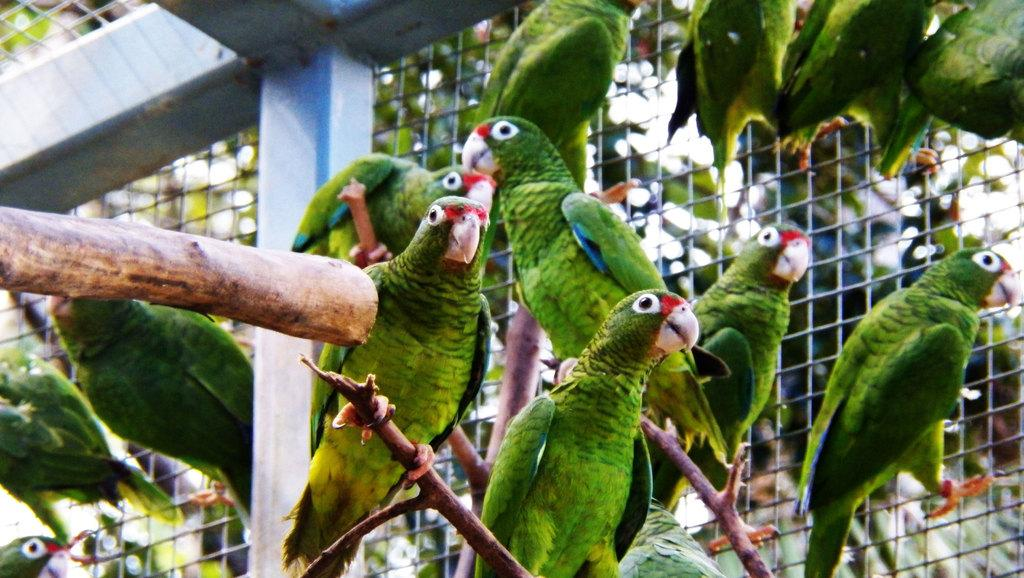What type of animals are in the image? There are parrots in the image. What objects are present in the image besides the parrots? There are wooden sticks in the image. What can be seen in the background of the image? There is a grill in the background of the image. Are the parrots wearing hats in the image? No, the parrots are not wearing hats in the image. Who are the parrots' partners or friends in the image? There is no indication of partners or friends for the parrots in the image. 